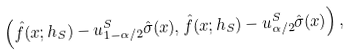Convert formula to latex. <formula><loc_0><loc_0><loc_500><loc_500>\left ( \hat { f } ( x ; h _ { S } ) - u ^ { S } _ { 1 - \alpha / 2 } \hat { \sigma } ( x ) , \hat { f } ( x ; h _ { S } ) - u ^ { S } _ { \alpha / 2 } \hat { \sigma } ( x ) \right ) ,</formula> 